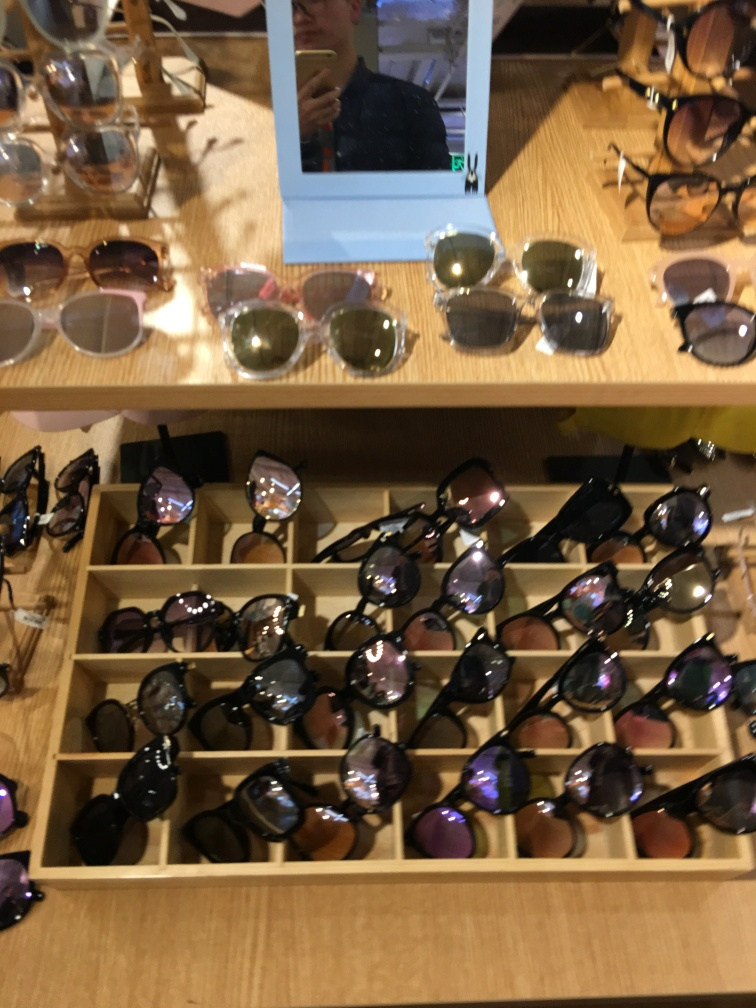Are there any quality issues with this image? Yes, the image suffers from motion blur and poor focus, which affects the sharpness and clarity of the sunglasses displayed. The composition could be improved for a more aesthetic presentation. 